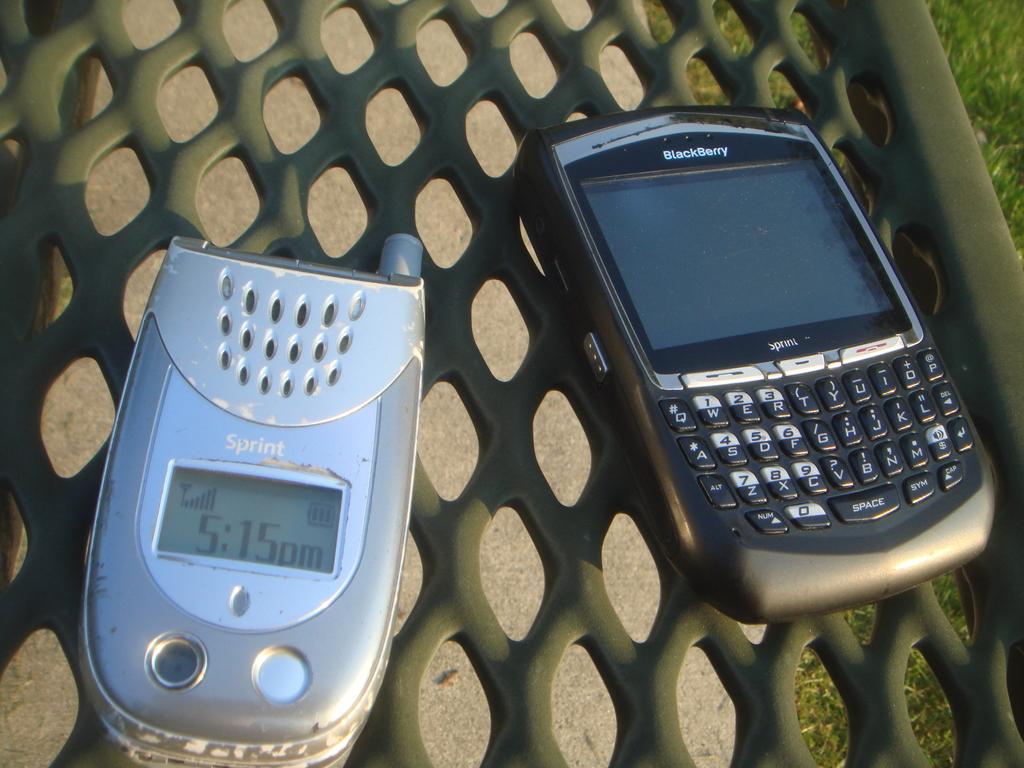What brand is the one on the right?
Give a very brief answer. Blackberry. What brand is the phone on the left?
Make the answer very short. Sprint. 